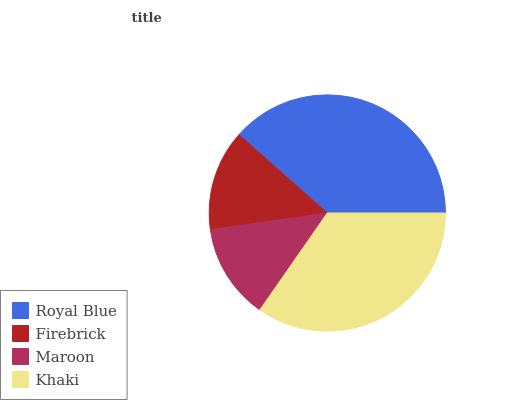Is Maroon the minimum?
Answer yes or no. Yes. Is Royal Blue the maximum?
Answer yes or no. Yes. Is Firebrick the minimum?
Answer yes or no. No. Is Firebrick the maximum?
Answer yes or no. No. Is Royal Blue greater than Firebrick?
Answer yes or no. Yes. Is Firebrick less than Royal Blue?
Answer yes or no. Yes. Is Firebrick greater than Royal Blue?
Answer yes or no. No. Is Royal Blue less than Firebrick?
Answer yes or no. No. Is Khaki the high median?
Answer yes or no. Yes. Is Firebrick the low median?
Answer yes or no. Yes. Is Royal Blue the high median?
Answer yes or no. No. Is Royal Blue the low median?
Answer yes or no. No. 